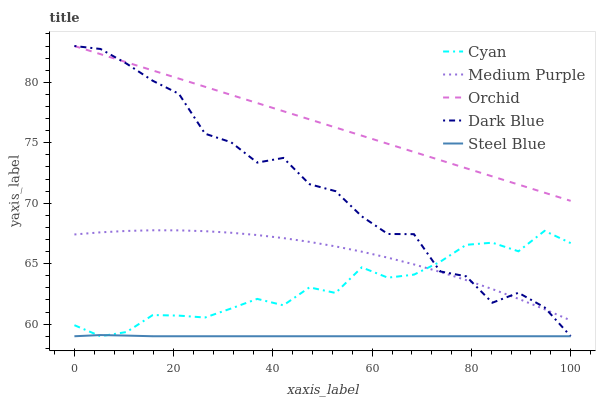Does Cyan have the minimum area under the curve?
Answer yes or no. No. Does Cyan have the maximum area under the curve?
Answer yes or no. No. Is Cyan the smoothest?
Answer yes or no. No. Is Cyan the roughest?
Answer yes or no. No. Does Orchid have the lowest value?
Answer yes or no. No. Does Cyan have the highest value?
Answer yes or no. No. Is Cyan less than Orchid?
Answer yes or no. Yes. Is Orchid greater than Steel Blue?
Answer yes or no. Yes. Does Cyan intersect Orchid?
Answer yes or no. No. 